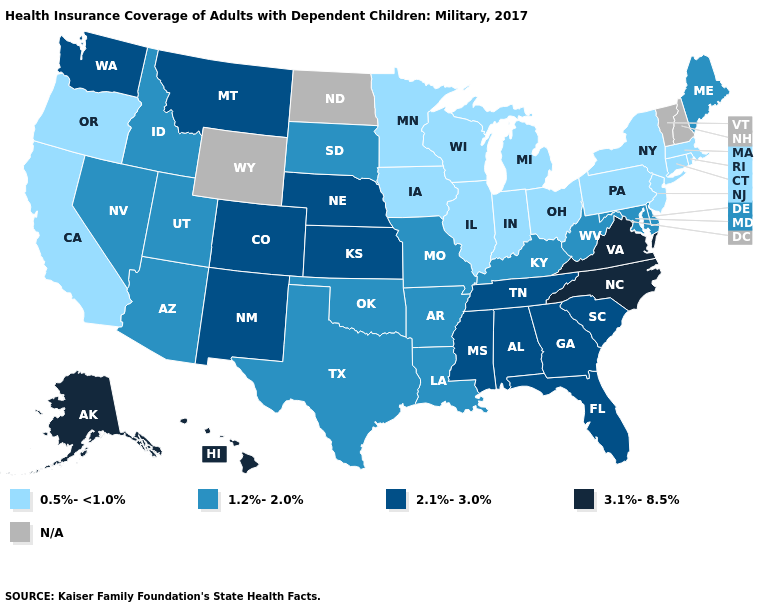Name the states that have a value in the range 0.5%-<1.0%?
Short answer required. California, Connecticut, Illinois, Indiana, Iowa, Massachusetts, Michigan, Minnesota, New Jersey, New York, Ohio, Oregon, Pennsylvania, Rhode Island, Wisconsin. Name the states that have a value in the range 0.5%-<1.0%?
Concise answer only. California, Connecticut, Illinois, Indiana, Iowa, Massachusetts, Michigan, Minnesota, New Jersey, New York, Ohio, Oregon, Pennsylvania, Rhode Island, Wisconsin. Does Maine have the highest value in the Northeast?
Give a very brief answer. Yes. Does the map have missing data?
Write a very short answer. Yes. Does Arizona have the highest value in the USA?
Write a very short answer. No. Does the map have missing data?
Write a very short answer. Yes. Name the states that have a value in the range 1.2%-2.0%?
Quick response, please. Arizona, Arkansas, Delaware, Idaho, Kentucky, Louisiana, Maine, Maryland, Missouri, Nevada, Oklahoma, South Dakota, Texas, Utah, West Virginia. Name the states that have a value in the range 1.2%-2.0%?
Concise answer only. Arizona, Arkansas, Delaware, Idaho, Kentucky, Louisiana, Maine, Maryland, Missouri, Nevada, Oklahoma, South Dakota, Texas, Utah, West Virginia. What is the highest value in the Northeast ?
Be succinct. 1.2%-2.0%. What is the value of Washington?
Quick response, please. 2.1%-3.0%. Name the states that have a value in the range 0.5%-<1.0%?
Concise answer only. California, Connecticut, Illinois, Indiana, Iowa, Massachusetts, Michigan, Minnesota, New Jersey, New York, Ohio, Oregon, Pennsylvania, Rhode Island, Wisconsin. Name the states that have a value in the range 2.1%-3.0%?
Give a very brief answer. Alabama, Colorado, Florida, Georgia, Kansas, Mississippi, Montana, Nebraska, New Mexico, South Carolina, Tennessee, Washington. 